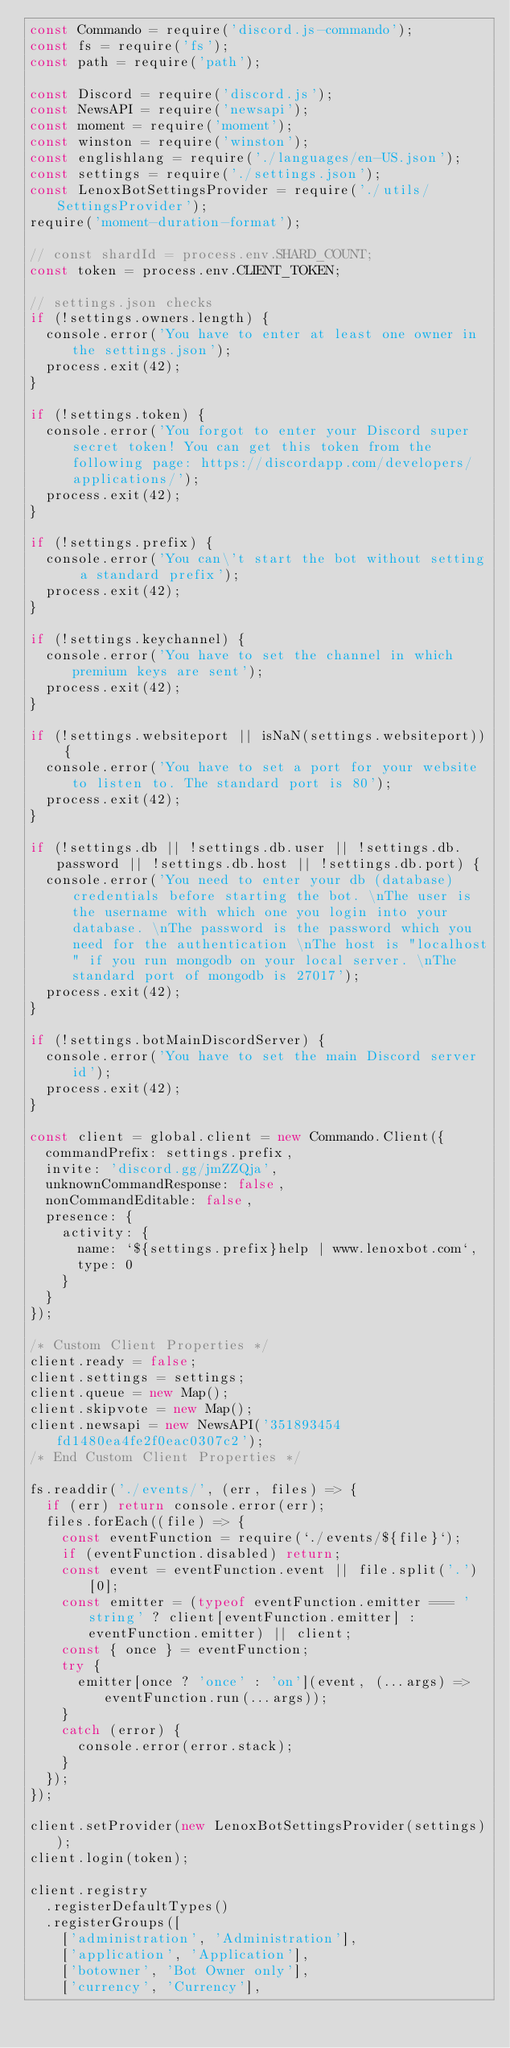Convert code to text. <code><loc_0><loc_0><loc_500><loc_500><_JavaScript_>const Commando = require('discord.js-commando');
const fs = require('fs');
const path = require('path');

const Discord = require('discord.js');
const NewsAPI = require('newsapi');
const moment = require('moment');
const winston = require('winston');
const englishlang = require('./languages/en-US.json');
const settings = require('./settings.json');
const LenoxBotSettingsProvider = require('./utils/SettingsProvider');
require('moment-duration-format');

// const shardId = process.env.SHARD_COUNT;
const token = process.env.CLIENT_TOKEN;

// settings.json checks
if (!settings.owners.length) {
  console.error('You have to enter at least one owner in the settings.json');
  process.exit(42);
}

if (!settings.token) {
  console.error('You forgot to enter your Discord super secret token! You can get this token from the following page: https://discordapp.com/developers/applications/');
  process.exit(42);
}

if (!settings.prefix) {
  console.error('You can\'t start the bot without setting a standard prefix');
  process.exit(42);
}

if (!settings.keychannel) {
  console.error('You have to set the channel in which premium keys are sent');
  process.exit(42);
}

if (!settings.websiteport || isNaN(settings.websiteport)) {
  console.error('You have to set a port for your website to listen to. The standard port is 80');
  process.exit(42);
}

if (!settings.db || !settings.db.user || !settings.db.password || !settings.db.host || !settings.db.port) {
  console.error('You need to enter your db (database) credentials before starting the bot. \nThe user is the username with which one you login into your database. \nThe password is the password which you need for the authentication \nThe host is "localhost" if you run mongodb on your local server. \nThe standard port of mongodb is 27017');
  process.exit(42);
}

if (!settings.botMainDiscordServer) {
  console.error('You have to set the main Discord server id');
  process.exit(42);
}

const client = global.client = new Commando.Client({
  commandPrefix: settings.prefix,
  invite: 'discord.gg/jmZZQja',
  unknownCommandResponse: false,
  nonCommandEditable: false,
  presence: {
    activity: {
      name: `${settings.prefix}help | www.lenoxbot.com`,
      type: 0
    }
  }
});

/* Custom Client Properties */
client.ready = false;
client.settings = settings;
client.queue = new Map();
client.skipvote = new Map();
client.newsapi = new NewsAPI('351893454fd1480ea4fe2f0eac0307c2');
/* End Custom Client Properties */

fs.readdir('./events/', (err, files) => {
  if (err) return console.error(err);
  files.forEach((file) => {
    const eventFunction = require(`./events/${file}`);
    if (eventFunction.disabled) return;
    const event = eventFunction.event || file.split('.')[0];
    const emitter = (typeof eventFunction.emitter === 'string' ? client[eventFunction.emitter] : eventFunction.emitter) || client;
    const { once } = eventFunction;
    try {
      emitter[once ? 'once' : 'on'](event, (...args) => eventFunction.run(...args));
    }
    catch (error) {
      console.error(error.stack);
    }
  });
});

client.setProvider(new LenoxBotSettingsProvider(settings));
client.login(token);

client.registry
  .registerDefaultTypes()
  .registerGroups([
    ['administration', 'Administration'],
    ['application', 'Application'],
    ['botowner', 'Bot Owner only'],
    ['currency', 'Currency'],</code> 